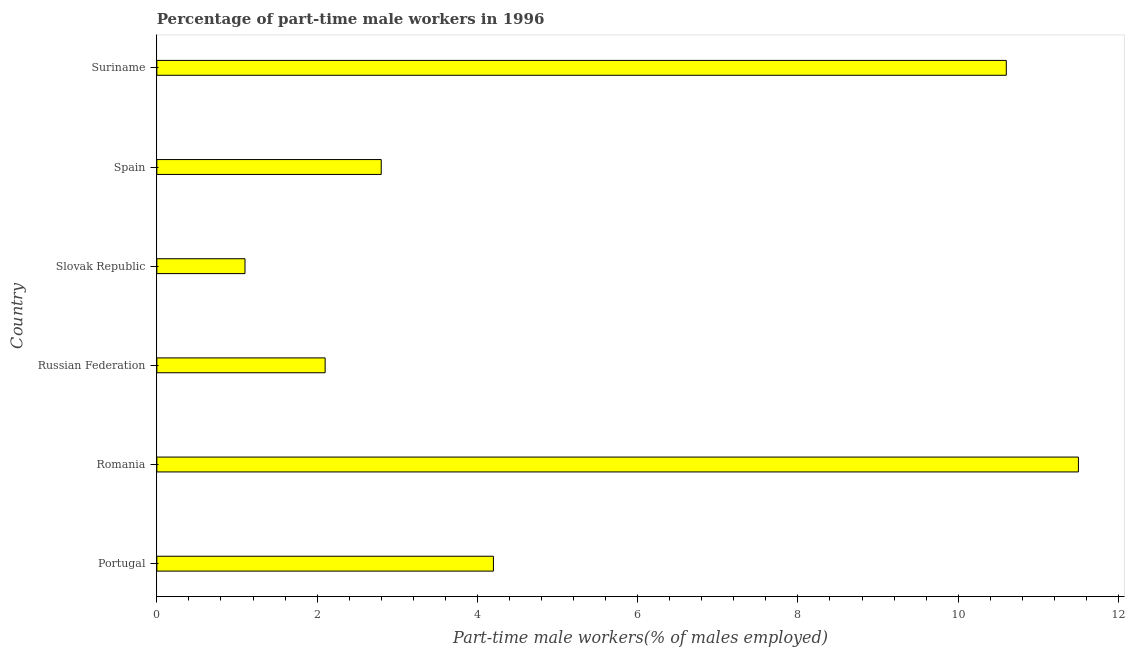What is the title of the graph?
Provide a succinct answer. Percentage of part-time male workers in 1996. What is the label or title of the X-axis?
Your answer should be compact. Part-time male workers(% of males employed). What is the percentage of part-time male workers in Suriname?
Offer a very short reply. 10.6. Across all countries, what is the minimum percentage of part-time male workers?
Give a very brief answer. 1.1. In which country was the percentage of part-time male workers maximum?
Your answer should be very brief. Romania. In which country was the percentage of part-time male workers minimum?
Provide a short and direct response. Slovak Republic. What is the sum of the percentage of part-time male workers?
Provide a succinct answer. 32.3. What is the average percentage of part-time male workers per country?
Give a very brief answer. 5.38. What is the median percentage of part-time male workers?
Provide a short and direct response. 3.5. In how many countries, is the percentage of part-time male workers greater than 2.4 %?
Your answer should be compact. 4. What is the ratio of the percentage of part-time male workers in Russian Federation to that in Slovak Republic?
Your answer should be compact. 1.91. What is the difference between the highest and the second highest percentage of part-time male workers?
Ensure brevity in your answer.  0.9. Is the sum of the percentage of part-time male workers in Russian Federation and Suriname greater than the maximum percentage of part-time male workers across all countries?
Make the answer very short. Yes. In how many countries, is the percentage of part-time male workers greater than the average percentage of part-time male workers taken over all countries?
Keep it short and to the point. 2. How many bars are there?
Give a very brief answer. 6. Are all the bars in the graph horizontal?
Make the answer very short. Yes. What is the difference between two consecutive major ticks on the X-axis?
Ensure brevity in your answer.  2. What is the Part-time male workers(% of males employed) of Portugal?
Give a very brief answer. 4.2. What is the Part-time male workers(% of males employed) of Russian Federation?
Give a very brief answer. 2.1. What is the Part-time male workers(% of males employed) in Slovak Republic?
Make the answer very short. 1.1. What is the Part-time male workers(% of males employed) in Spain?
Make the answer very short. 2.8. What is the Part-time male workers(% of males employed) in Suriname?
Provide a succinct answer. 10.6. What is the difference between the Part-time male workers(% of males employed) in Portugal and Romania?
Make the answer very short. -7.3. What is the difference between the Part-time male workers(% of males employed) in Portugal and Slovak Republic?
Your response must be concise. 3.1. What is the difference between the Part-time male workers(% of males employed) in Romania and Slovak Republic?
Keep it short and to the point. 10.4. What is the difference between the Part-time male workers(% of males employed) in Romania and Spain?
Provide a short and direct response. 8.7. What is the difference between the Part-time male workers(% of males employed) in Romania and Suriname?
Make the answer very short. 0.9. What is the difference between the Part-time male workers(% of males employed) in Russian Federation and Suriname?
Make the answer very short. -8.5. What is the difference between the Part-time male workers(% of males employed) in Slovak Republic and Spain?
Offer a very short reply. -1.7. What is the difference between the Part-time male workers(% of males employed) in Spain and Suriname?
Your answer should be very brief. -7.8. What is the ratio of the Part-time male workers(% of males employed) in Portugal to that in Romania?
Provide a succinct answer. 0.36. What is the ratio of the Part-time male workers(% of males employed) in Portugal to that in Slovak Republic?
Your answer should be compact. 3.82. What is the ratio of the Part-time male workers(% of males employed) in Portugal to that in Suriname?
Give a very brief answer. 0.4. What is the ratio of the Part-time male workers(% of males employed) in Romania to that in Russian Federation?
Your answer should be very brief. 5.48. What is the ratio of the Part-time male workers(% of males employed) in Romania to that in Slovak Republic?
Offer a terse response. 10.46. What is the ratio of the Part-time male workers(% of males employed) in Romania to that in Spain?
Offer a terse response. 4.11. What is the ratio of the Part-time male workers(% of males employed) in Romania to that in Suriname?
Your answer should be very brief. 1.08. What is the ratio of the Part-time male workers(% of males employed) in Russian Federation to that in Slovak Republic?
Offer a terse response. 1.91. What is the ratio of the Part-time male workers(% of males employed) in Russian Federation to that in Suriname?
Keep it short and to the point. 0.2. What is the ratio of the Part-time male workers(% of males employed) in Slovak Republic to that in Spain?
Ensure brevity in your answer.  0.39. What is the ratio of the Part-time male workers(% of males employed) in Slovak Republic to that in Suriname?
Your answer should be compact. 0.1. What is the ratio of the Part-time male workers(% of males employed) in Spain to that in Suriname?
Your answer should be compact. 0.26. 